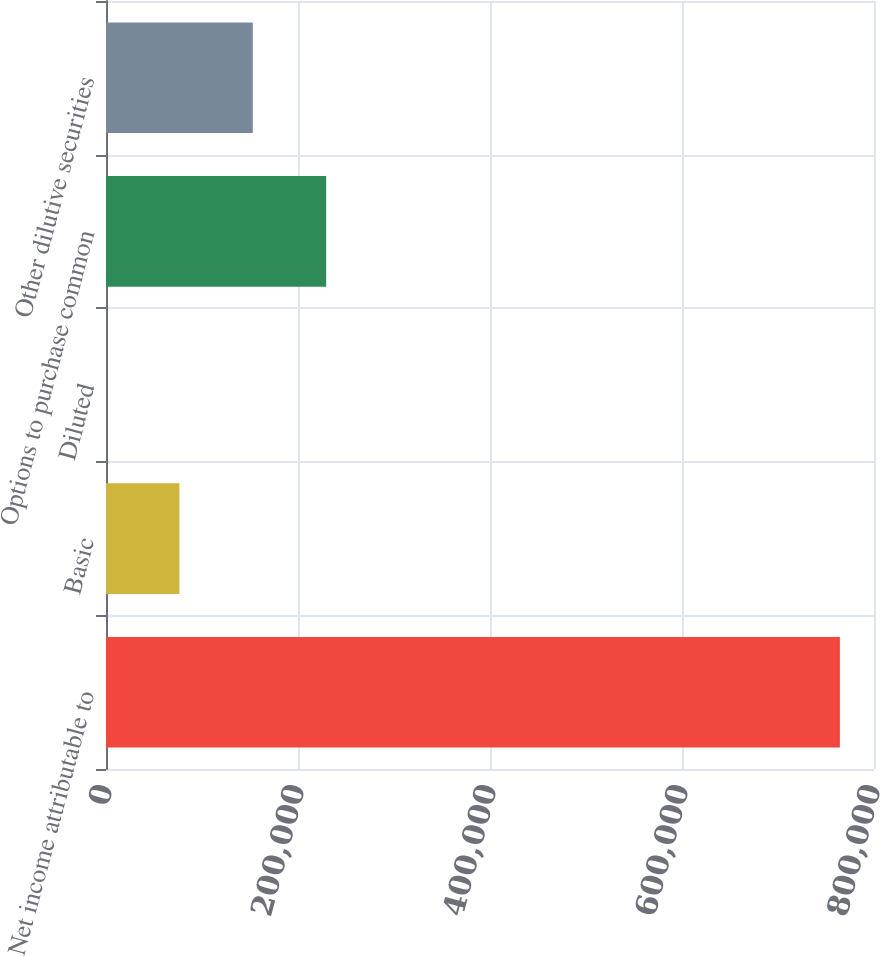Convert chart to OTSL. <chart><loc_0><loc_0><loc_500><loc_500><bar_chart><fcel>Net income attributable to<fcel>Basic<fcel>Diluted<fcel>Options to purchase common<fcel>Other dilutive securities<nl><fcel>764465<fcel>76451.6<fcel>5.7<fcel>229343<fcel>152898<nl></chart> 